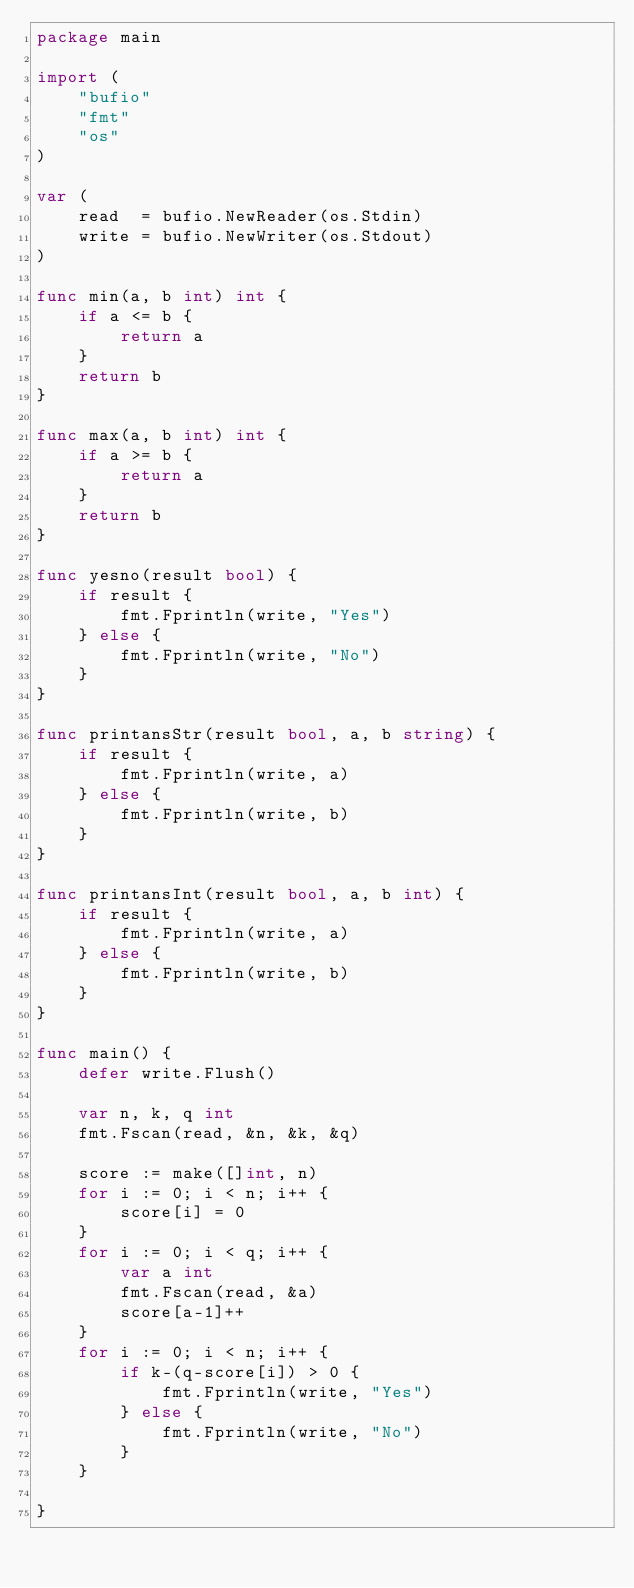Convert code to text. <code><loc_0><loc_0><loc_500><loc_500><_Go_>package main

import (
	"bufio"
	"fmt"
	"os"
)

var (
	read  = bufio.NewReader(os.Stdin)
	write = bufio.NewWriter(os.Stdout)
)

func min(a, b int) int {
	if a <= b {
		return a
	}
	return b
}

func max(a, b int) int {
	if a >= b {
		return a
	}
	return b
}

func yesno(result bool) {
	if result {
		fmt.Fprintln(write, "Yes")
	} else {
		fmt.Fprintln(write, "No")
	}
}

func printansStr(result bool, a, b string) {
	if result {
		fmt.Fprintln(write, a)
	} else {
		fmt.Fprintln(write, b)
	}
}

func printansInt(result bool, a, b int) {
	if result {
		fmt.Fprintln(write, a)
	} else {
		fmt.Fprintln(write, b)
	}
}

func main() {
	defer write.Flush()

	var n, k, q int
	fmt.Fscan(read, &n, &k, &q)

	score := make([]int, n)
	for i := 0; i < n; i++ {
		score[i] = 0
	}
	for i := 0; i < q; i++ {
		var a int
		fmt.Fscan(read, &a)
		score[a-1]++
	}
	for i := 0; i < n; i++ {
		if k-(q-score[i]) > 0 {
			fmt.Fprintln(write, "Yes")
		} else {
			fmt.Fprintln(write, "No")
		}
	}

}
</code> 